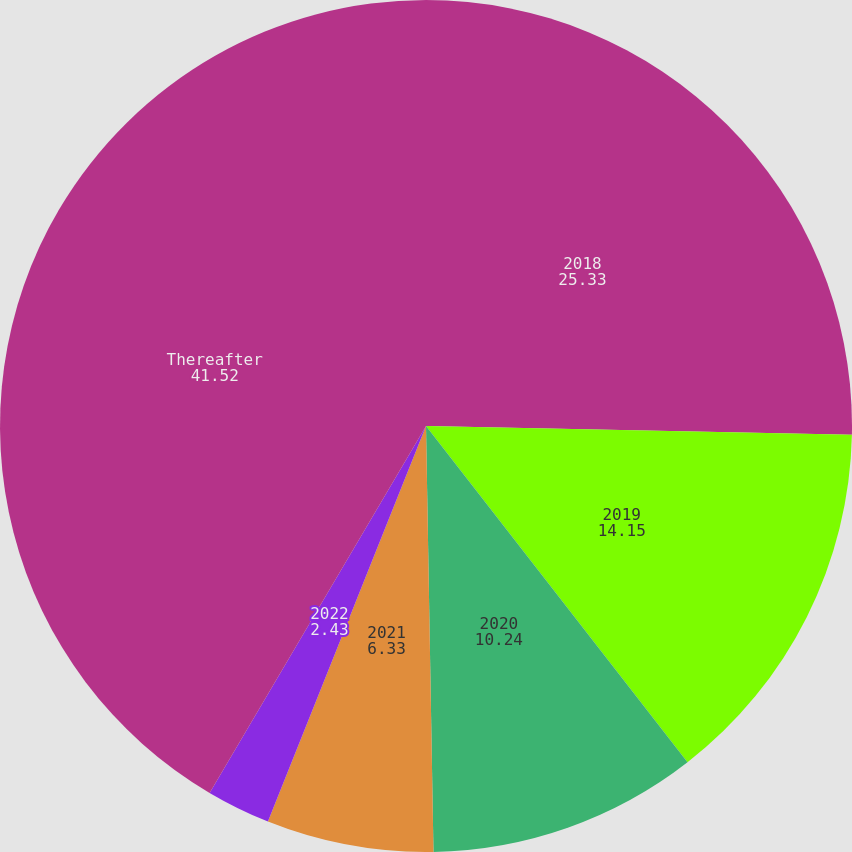<chart> <loc_0><loc_0><loc_500><loc_500><pie_chart><fcel>2018<fcel>2019<fcel>2020<fcel>2021<fcel>2022<fcel>Thereafter<nl><fcel>25.33%<fcel>14.15%<fcel>10.24%<fcel>6.33%<fcel>2.43%<fcel>41.52%<nl></chart> 